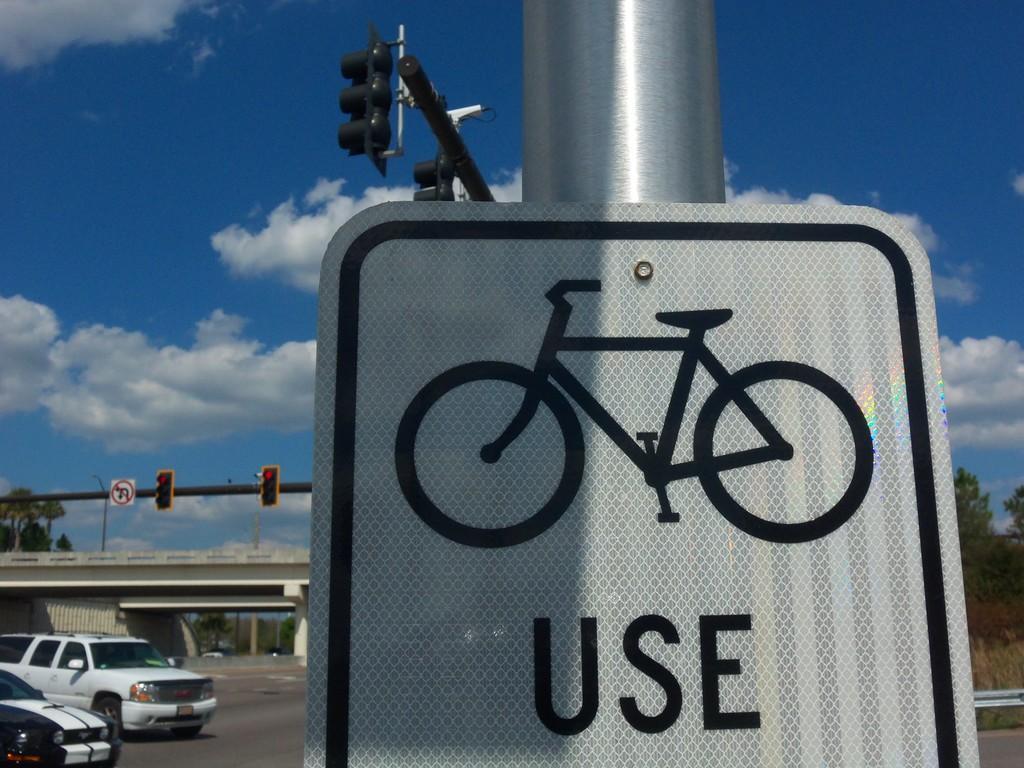How would you summarize this image in a sentence or two? Here we can see a board on the pole. In the background there are vehicles on the road,bridge,trees,traffic signal poles,sign board pole,grass and clouds in the sky. 